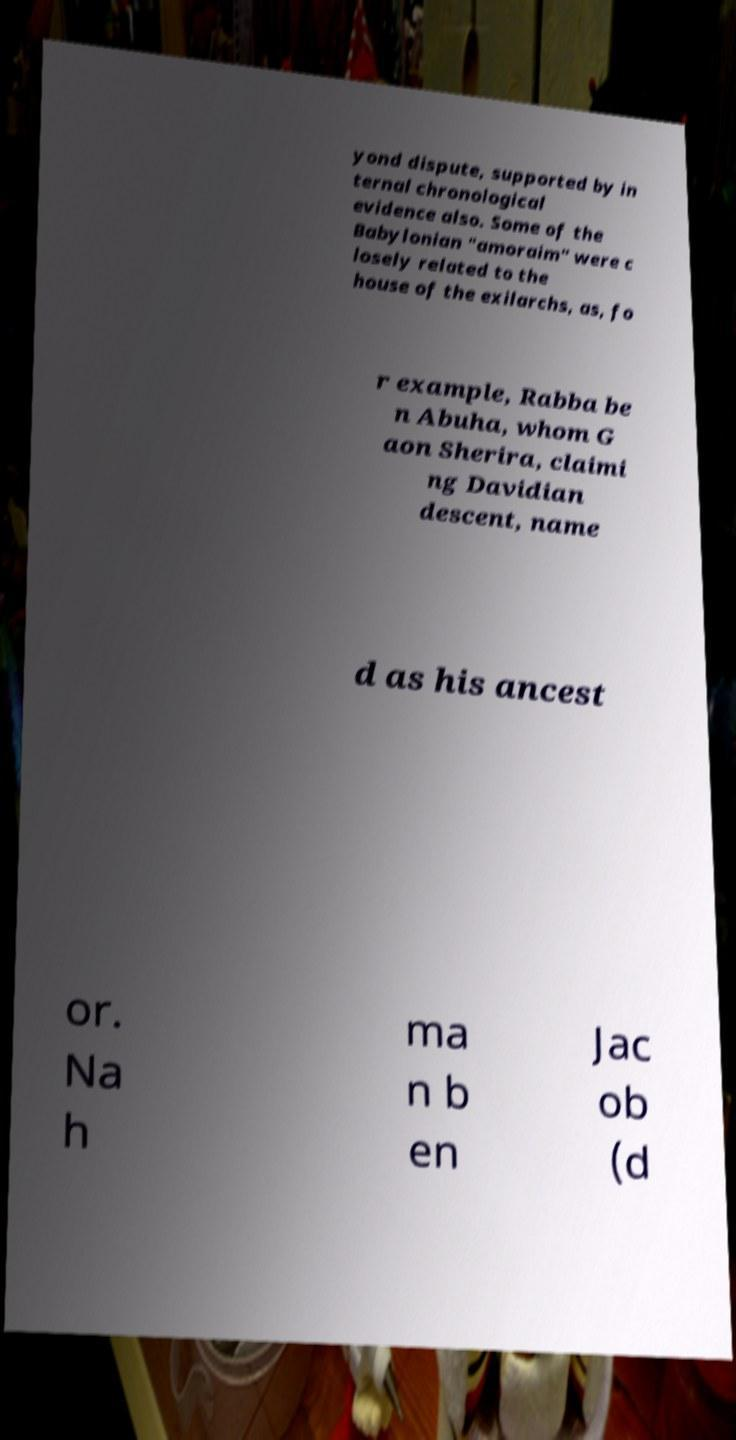Can you read and provide the text displayed in the image?This photo seems to have some interesting text. Can you extract and type it out for me? yond dispute, supported by in ternal chronological evidence also. Some of the Babylonian "amoraim" were c losely related to the house of the exilarchs, as, fo r example, Rabba be n Abuha, whom G aon Sherira, claimi ng Davidian descent, name d as his ancest or. Na h ma n b en Jac ob (d 